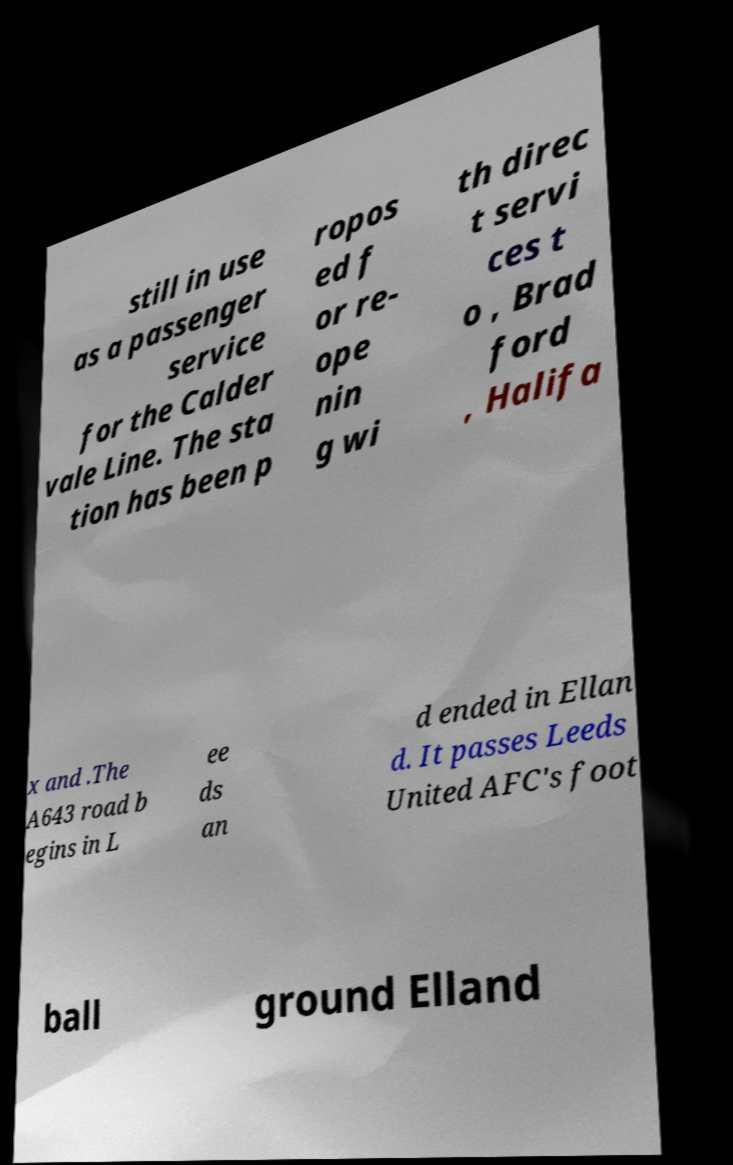Can you accurately transcribe the text from the provided image for me? still in use as a passenger service for the Calder vale Line. The sta tion has been p ropos ed f or re- ope nin g wi th direc t servi ces t o , Brad ford , Halifa x and .The A643 road b egins in L ee ds an d ended in Ellan d. It passes Leeds United AFC's foot ball ground Elland 